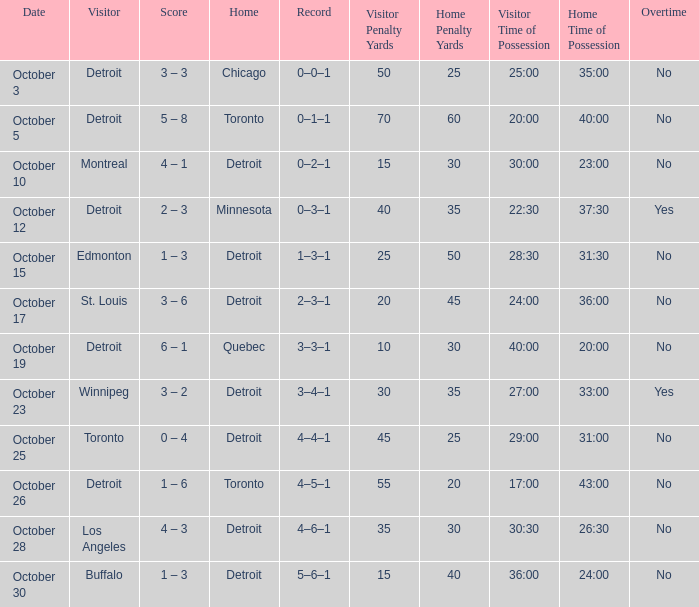Name the home with toronto visiting Detroit. 